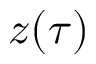Convert formula to latex. <formula><loc_0><loc_0><loc_500><loc_500>z ( \tau )</formula> 